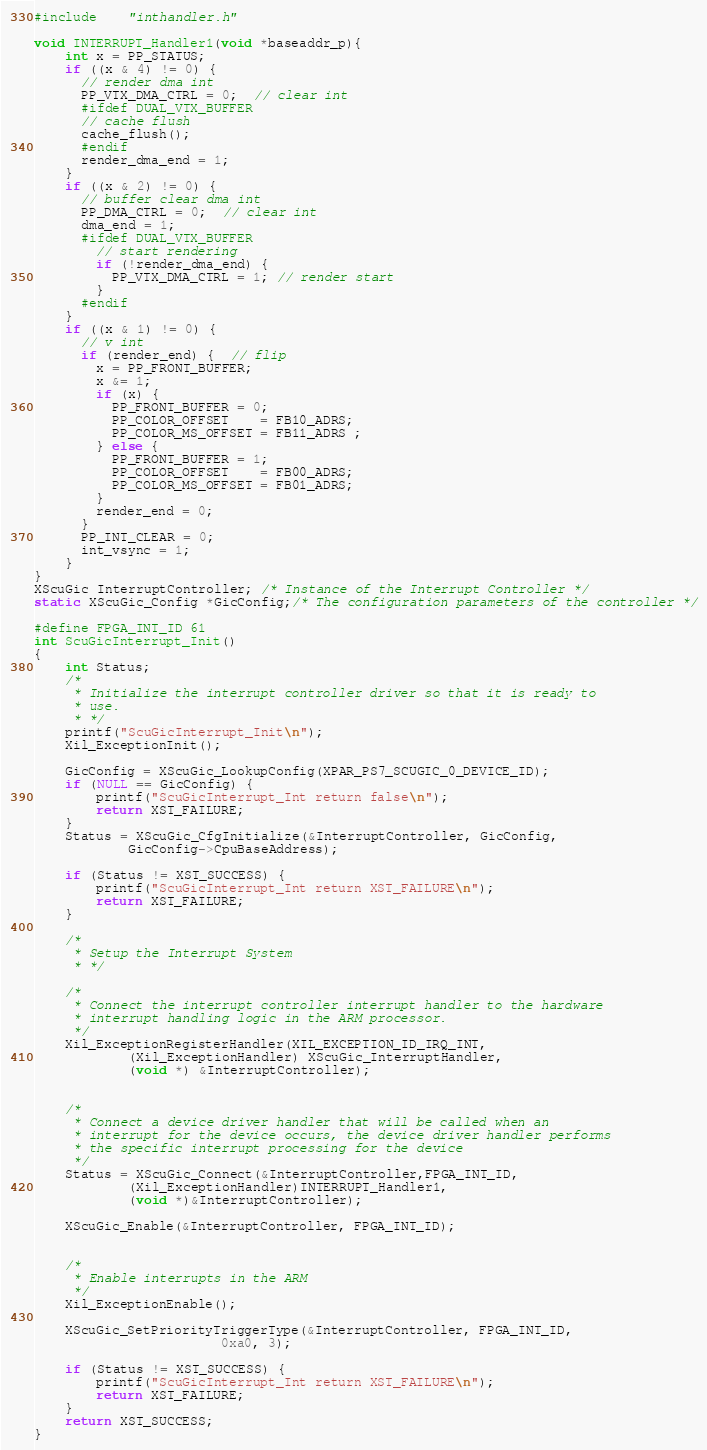<code> <loc_0><loc_0><loc_500><loc_500><_C_>#include    "inthandler.h"

void INTERRUPT_Handler1(void *baseaddr_p){
	int x = PP_STATUS;
	if ((x & 4) != 0) {
	  // render dma int
	  PP_VTX_DMA_CTRL = 0;  // clear int
	  #ifdef DUAL_VTX_BUFFER
	  // cache flush
	  cache_flush();
	  #endif
	  render_dma_end = 1;
	}
	if ((x & 2) != 0) {
	  // buffer clear dma int
	  PP_DMA_CTRL = 0;  // clear int
	  dma_end = 1;
	  #ifdef DUAL_VTX_BUFFER
	    // start rendering
	    if (!render_dma_end) {
	      PP_VTX_DMA_CTRL = 1; // render start
	    }
      #endif
	}
	if ((x & 1) != 0) {
      // v int
	  if (render_end) {  // flip
	    x = PP_FRONT_BUFFER;
	    x &= 1;
	    if (x) {
	      PP_FRONT_BUFFER = 0;
	      PP_COLOR_OFFSET    = FB10_ADRS;
	      PP_COLOR_MS_OFFSET = FB11_ADRS ;
	    } else {
	      PP_FRONT_BUFFER = 1;
	      PP_COLOR_OFFSET    = FB00_ADRS;
	      PP_COLOR_MS_OFFSET = FB01_ADRS;
	    }
	    render_end = 0;
	  }
      PP_INT_CLEAR = 0;
	  int_vsync = 1;
 	}
}
XScuGic InterruptController; /* Instance of the Interrupt Controller */
static XScuGic_Config *GicConfig;/* The configuration parameters of the controller */

#define FPGA_INT_ID 61
int ScuGicInterrupt_Init()
{
	int Status;
	/*
	 * Initialize the interrupt controller driver so that it is ready to
	 * use.
	 * */
	printf("ScuGicInterrupt_Init\n");
	Xil_ExceptionInit();

	GicConfig = XScuGic_LookupConfig(XPAR_PS7_SCUGIC_0_DEVICE_ID);
	if (NULL == GicConfig) {
		printf("ScuGicInterrupt_Int return false\n");
		return XST_FAILURE;
	}
	Status = XScuGic_CfgInitialize(&InterruptController, GicConfig,
			GicConfig->CpuBaseAddress);

	if (Status != XST_SUCCESS) {
		printf("ScuGicInterrupt_Int return XST_FAILURE\n");
		return XST_FAILURE;
	}

	/*
	 * Setup the Interrupt System
	 * */

	/*
	 * Connect the interrupt controller interrupt handler to the hardware
	 * interrupt handling logic in the ARM processor.
	 */
	Xil_ExceptionRegisterHandler(XIL_EXCEPTION_ID_IRQ_INT,
			(Xil_ExceptionHandler) XScuGic_InterruptHandler,
			(void *) &InterruptController);


	/*
	 * Connect a device driver handler that will be called when an
	 * interrupt for the device occurs, the device driver handler performs
	 * the specific interrupt processing for the device
	 */
	Status = XScuGic_Connect(&InterruptController,FPGA_INT_ID,
			(Xil_ExceptionHandler)INTERRUPT_Handler1,
			(void *)&InterruptController);

	XScuGic_Enable(&InterruptController, FPGA_INT_ID);


	/*
	 * Enable interrupts in the ARM
	 */
	Xil_ExceptionEnable();

	XScuGic_SetPriorityTriggerType(&InterruptController, FPGA_INT_ID,
						0xa0, 3);

	if (Status != XST_SUCCESS) {
		printf("ScuGicInterrupt_Int return XST_FAILURE\n");
		return XST_FAILURE;
	}
	return XST_SUCCESS;
}
</code> 